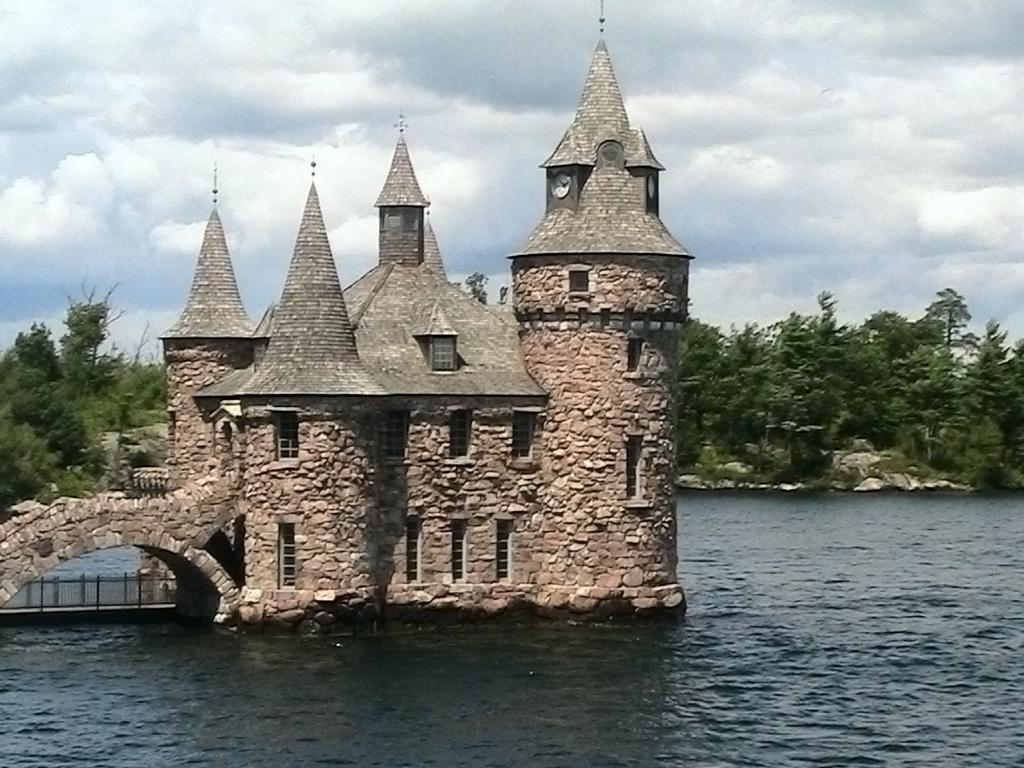What is the main structure in the foreground of the image? There is a building in the foreground of the image. What type of natural elements can be seen in the background of the image? There are trees in the background of the image. What is visible at the top of the image? The sky is visible at the top of the image. What type of terrain is present at the bottom of the image? Water is present at the bottom of the image. Reasoning: Let' Let's think step by step in order to produce the conversation. We start by identifying the main structure in the foreground, which is the building. Then, we describe the natural elements in the background, which are the trees. Next, we mention the sky visible at the top of the image. Finally, we identify the terrain at the bottom of the image, which is water. Each question is designed to elicit a specific detail about the image that is known from the provided facts. Absurd Question/Answer: How many bulbs are hanging from the trees in the image? There are no bulbs present in the image; it features a building, trees, sky, and water. Can you see anyone's nose in the image? There is no person's nose visible in the image. How many bulbs are hanging from the trees in the image? There are no bulbs present in the image; it features a building, trees, sky, and water. Can you see anyone's nose in the image? There is no person's nose visible in the image. 